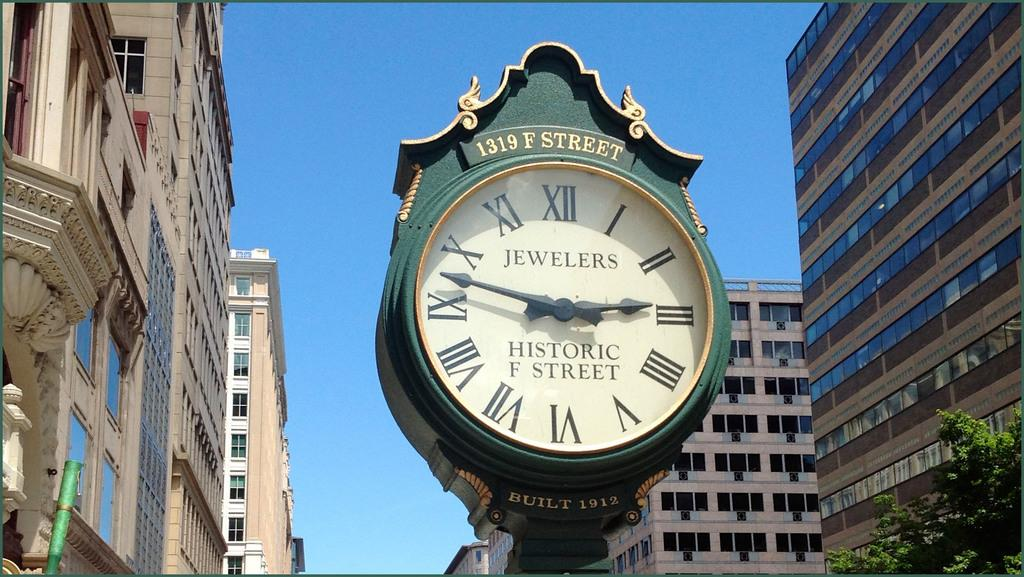<image>
Share a concise interpretation of the image provided. Green clock which says 1319 F Street on the top. 